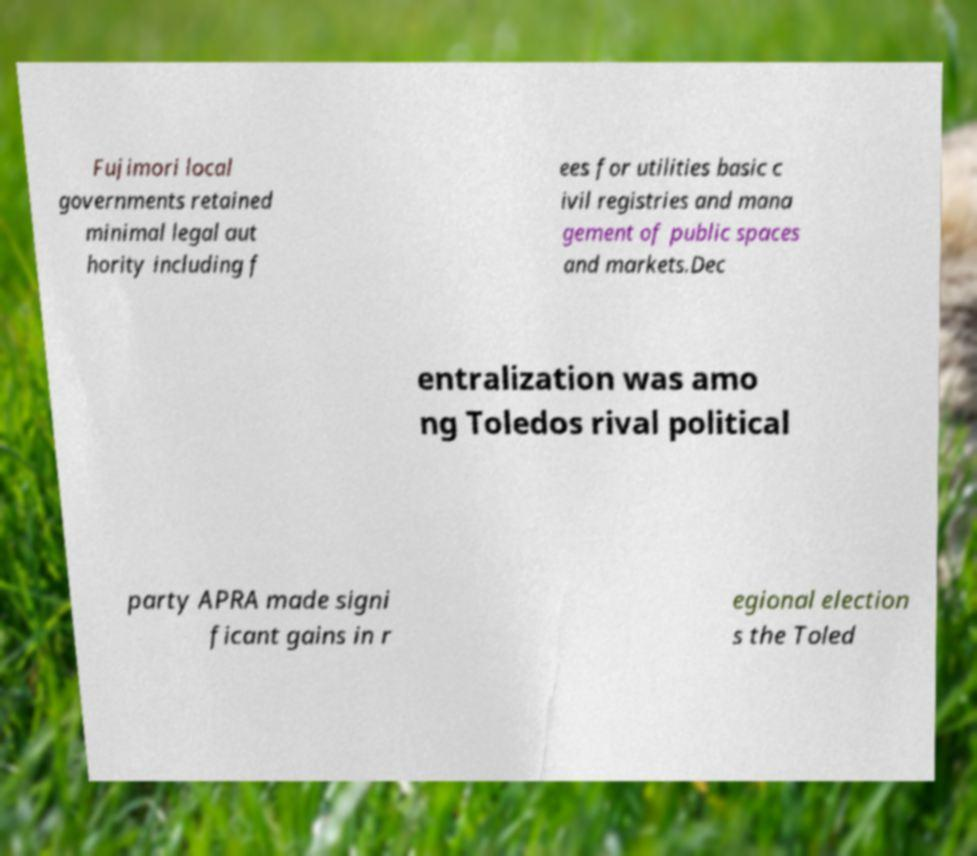For documentation purposes, I need the text within this image transcribed. Could you provide that? Fujimori local governments retained minimal legal aut hority including f ees for utilities basic c ivil registries and mana gement of public spaces and markets.Dec entralization was amo ng Toledos rival political party APRA made signi ficant gains in r egional election s the Toled 